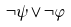Convert formula to latex. <formula><loc_0><loc_0><loc_500><loc_500>\neg \psi \vee \neg \varphi</formula> 